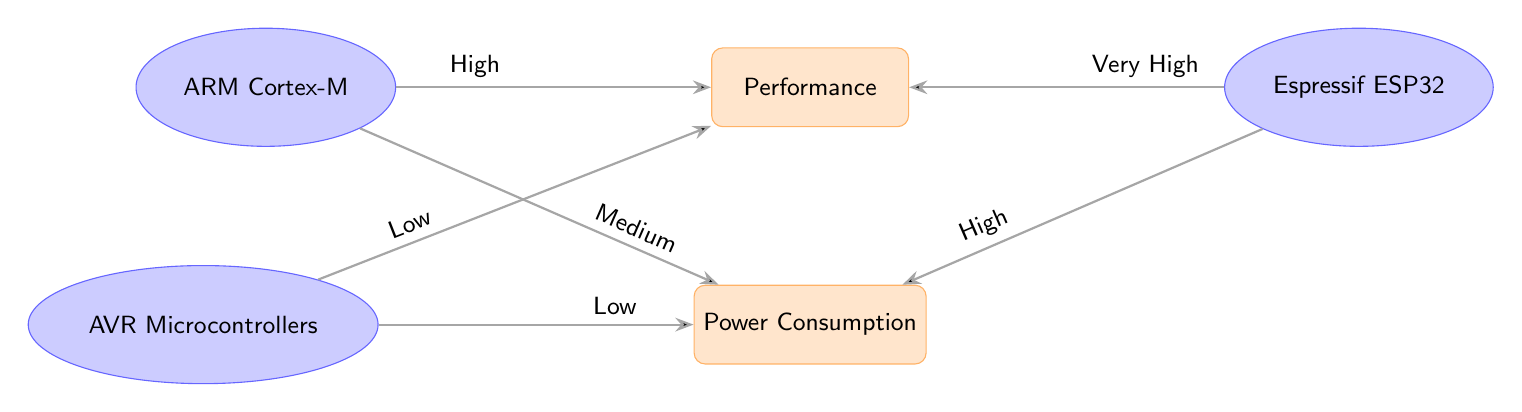What is the performance level of the ARM Cortex-M microcontroller? The diagram shows an arrow from the ARM Cortex-M to the Performance attribute labeled "High". This indicates that the performance level is categorized as high for the ARM Cortex-M microcontroller.
Answer: High What is the power consumption level of the AVR microcontroller? The diagram shows an arrow from the AVR Microcontroller to the Power Consumption attribute labeled "Low". This indicates that the power consumption level is low for the AVR microcontroller.
Answer: Low How many microcontrollers are represented in the diagram? The diagram includes three microcontroller nodes: ARM Cortex-M, AVR Microcontrollers, and Espressif ESP32. Therefore, the total count of microcontrollers is three.
Answer: Three Which microcontroller has both high performance and high power consumption? The diagram indicates an arrow from the Espressif ESP32 to both the Performance attribute labeled "Very High" and the Power Consumption attribute labeled "High". This signifies that the Espressif ESP32 has both high performance and high power consumption.
Answer: Espressif ESP32 Which microcontroller has low performance and low power consumption? The diagram shows the AVR Microcontrollers linked to both the Performance attribute (labeled "Low") and the Power Consumption attribute (labeled "Low"). This reveals that the AVR Microcontrollers correspond to both low performance and low power consumption.
Answer: AVR Microcontrollers What comparative performance characteristic does the Espressif ESP32 have over the AVR microcontroller? The performance of the Espressif ESP32 is denoted as "Very High" while the performance of the AVR is marked as "Low". This indicates that the Espressif ESP32 has a significantly better performance characteristic compared to the AVR microcontroller.
Answer: Very High vs. Low What is the relationship between the power consumption of ARM Cortex-M and AVR microcontrollers? The ARM Cortex-M is connected to the Power Consumption attribute labeled "Medium", and the AVR microcontroller is connected to the same attribute labeled "Low". This means that the ARM Cortex-M consumes more power than the AVR microcontroller.
Answer: Medium vs. Low What type of diagram is this? The structure of the diagram features nodes representing microcontrollers and attributes, connected by directed edges illustrating their relationships. This specifically categorizes it as a comparison diagram.
Answer: Comparison diagram 